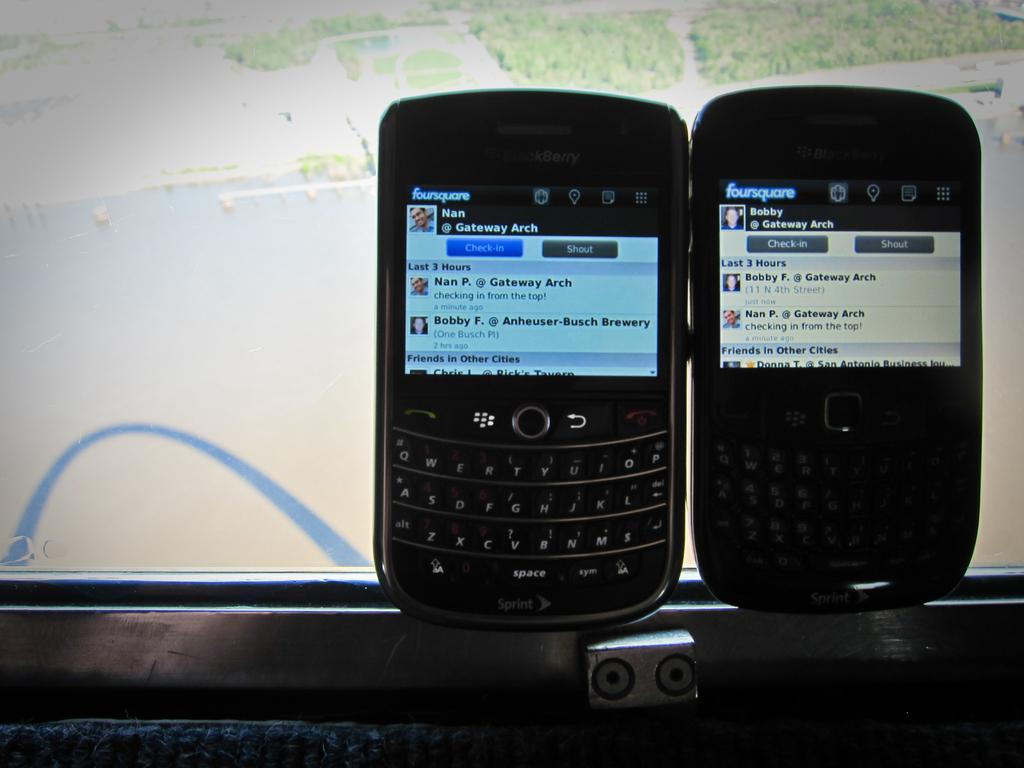<image>
Give a short and clear explanation of the subsequent image. Two phones are sitting side by side and both are displaying the foursquare app. 